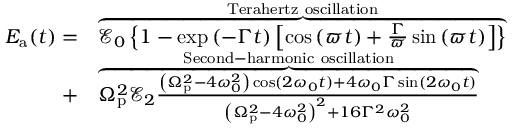Convert formula to latex. <formula><loc_0><loc_0><loc_500><loc_500>\begin{array} { r l } { E _ { a } ( t ) = } & { \overbrace { \ m a t h s c r { E } _ { 0 } \left \{ 1 - \exp { \left ( - \Gamma t \right ) } \left [ \cos \left ( \varpi t \right ) + \frac { \Gamma } { \varpi } \sin \left ( \varpi t \right ) \right ] \right \} } ^ { T e r a h e r t z o s c i l l a t i o n } } \\ { + } & { \overbrace { \Omega _ { p } ^ { 2 } \ m a t h s c r { E } _ { 2 } \frac { \left ( \Omega _ { p } ^ { 2 } - 4 \omega _ { 0 } ^ { 2 } \right ) \cos ( 2 \omega _ { 0 } t ) + 4 \omega _ { 0 } \Gamma \sin ( 2 \omega _ { 0 } t ) } { \left ( \Omega _ { p } ^ { 2 } - 4 \omega _ { 0 } ^ { 2 } \right ) ^ { 2 } + 1 6 \Gamma ^ { 2 } \omega _ { 0 } ^ { 2 } } } ^ { S e c o n d - h a r m o n i c o s c i l l a t i o n } } \end{array}</formula> 